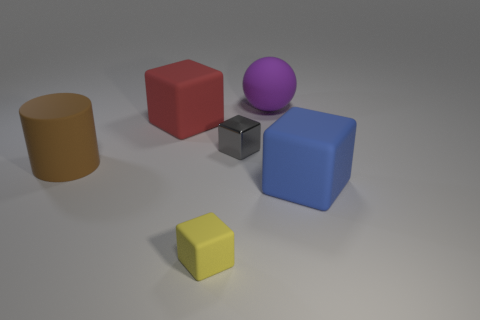How many blue blocks have the same material as the big cylinder?
Ensure brevity in your answer.  1. What number of tiny objects are the same shape as the big blue matte object?
Offer a terse response. 2. Are there an equal number of brown cylinders that are behind the brown rubber cylinder and blue matte blocks?
Keep it short and to the point. No. What is the color of the rubber cylinder that is the same size as the purple matte ball?
Ensure brevity in your answer.  Brown. Are there any small yellow matte objects that have the same shape as the shiny thing?
Your answer should be compact. Yes. There is a large block that is to the left of the big rubber thing behind the big block behind the large brown cylinder; what is its material?
Provide a short and direct response. Rubber. How many other things are there of the same size as the purple thing?
Ensure brevity in your answer.  3. What color is the small metallic thing?
Ensure brevity in your answer.  Gray. How many rubber objects are either big cubes or purple balls?
Make the answer very short. 3. Is there anything else that is the same material as the gray object?
Keep it short and to the point. No. 